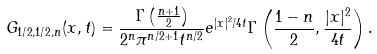<formula> <loc_0><loc_0><loc_500><loc_500>G _ { 1 / 2 , 1 / 2 , n } ( x , t ) = \frac { \Gamma \left ( \frac { n + 1 } { 2 } \right ) } { 2 ^ { n } \pi ^ { n / 2 + 1 } t ^ { n / 2 } } e ^ { { | x | ^ { 2 } } / { 4 t } } \Gamma \left ( \frac { 1 - n } { 2 } , \frac { | x | ^ { 2 } } { 4 t } \right ) .</formula> 